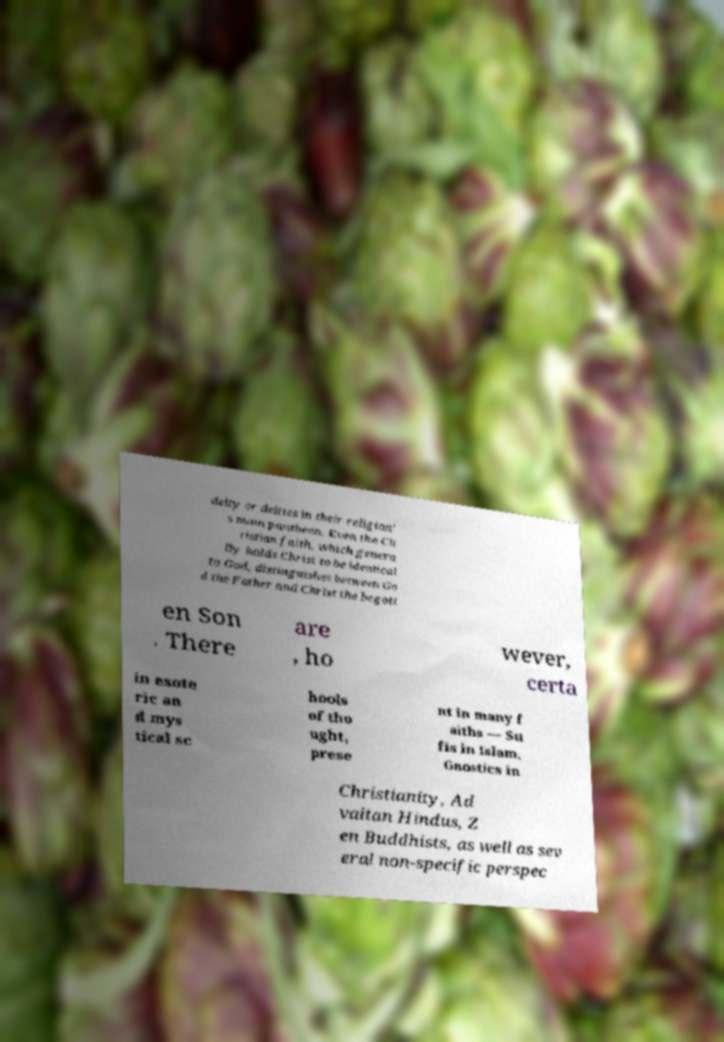Please read and relay the text visible in this image. What does it say? deity or deities in their religion' s main pantheon. Even the Ch ristian faith, which genera lly holds Christ to be identical to God, distinguishes between Go d the Father and Christ the begott en Son . There are , ho wever, certa in esote ric an d mys tical sc hools of tho ught, prese nt in many f aiths — Su fis in Islam, Gnostics in Christianity, Ad vaitan Hindus, Z en Buddhists, as well as sev eral non-specific perspec 